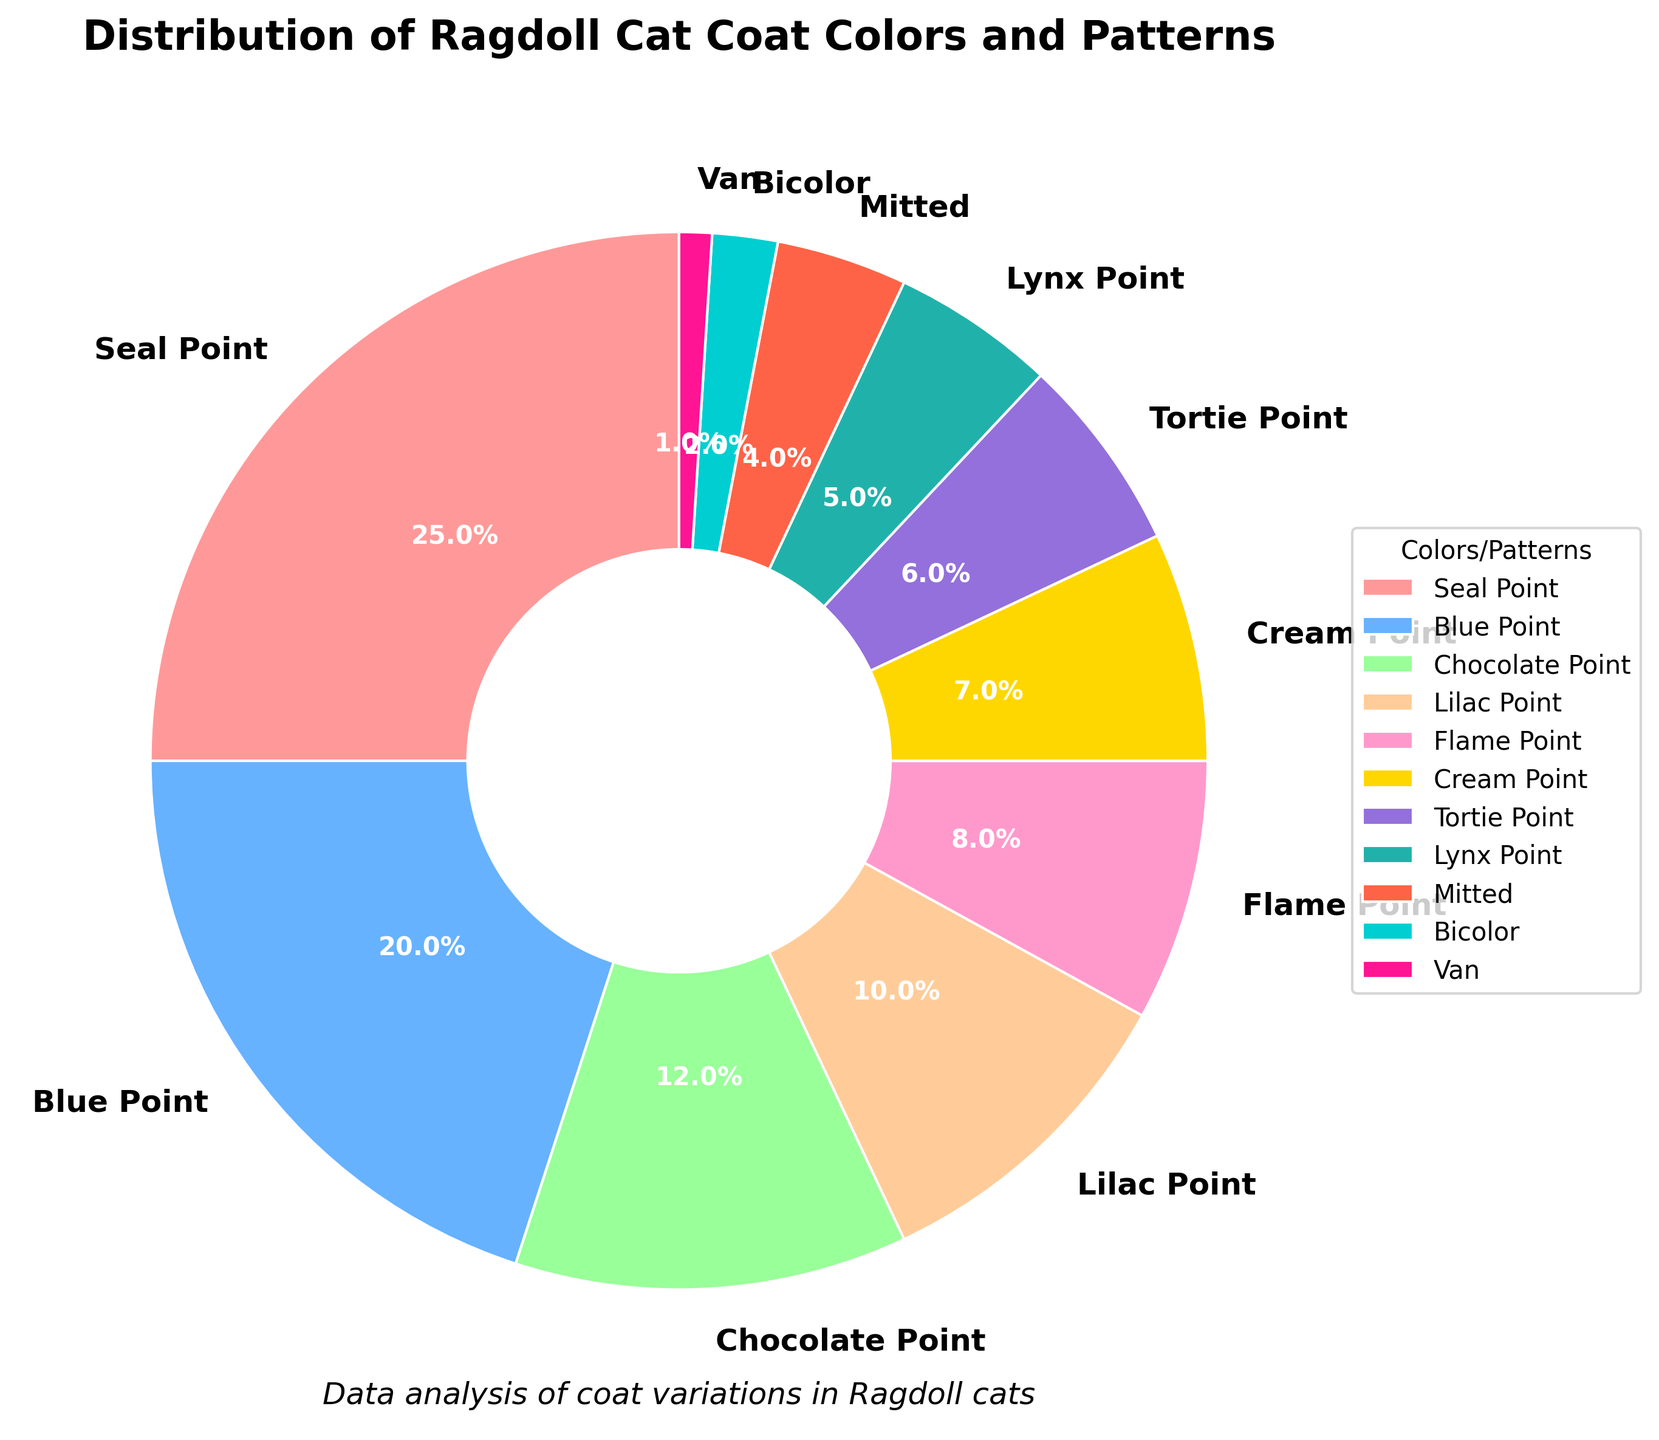What is the most common coat color/pattern in Ragdoll cats? The figure shows a pie chart. The largest segment represents the Seal Point, which has a larger portion than any other color/pattern.
Answer: Seal Point Which coat color/pattern contributes the least to the distribution? The pie chart's smallest segment corresponds to the "Van" color/pattern, consisting of 1% of the total distribution.
Answer: Van What is the combined percentage of Seal Point and Blue Point in Ragdoll cats? Adding the percentages for Seal Point (25%) and Blue Point (20%), the calculation is 25% + 20% = 45%.
Answer: 45% How does the prevalence of Mitted compare to Bicolor? The pie chart indicates that Mitted has 4% while Bicolor has 2%. Comparing these, Mitted is twice as prevalent as Bicolor.
Answer: Mitted is twice as much as Bicolor Which two coat colors/patterns together make up exactly 17%? By examining the chart, the percentages for Cream Point (7%) and Tortie Point (6%) add up to 13%. The correct pair, which totals 17%, is Lilac Point (10%) and Flame Point (8%).
Answer: Lilac Point and Flame Point What is the difference in percentage between Seal Point and Lynx Point? Subtracting the Lynx Point (5%) from Seal Point (25%), the difference is 25% - 5% = 20%.
Answer: 20% Which has a higher percentage, Chocolate Point or Lilac Point and by how much? Chocolate Point is 12% while Lilac Point is 10%. The difference is calculated by 12% - 10% = 2%.
Answer: Chocolate Point by 2% How many coat colors/patterns are represented in the pie chart? Counting each segment in the pie chart, there are a total of 11 different coat colors/patterns displayed.
Answer: 11 What is the median value of the percentages for the coat colors/patterns? Organizing the percentages in ascending order: 1, 2, 4, 5, 6, 7, 8, 10, 12, 20, 25, the middle value in this list (6th position) is 7%.
Answer: 7% If you combine all point patterns (Seal, Blue, Chocolate, Lilac, Flame, Cream, Tortie, and Lynx), what percentage do they form together? Adding the percentages: Seal Point (25), Blue Point (20), Chocolate Point (12), Lilac Point (10), Flame Point (8), Cream Point (7), Tortie Point (6), and Lynx Point (5), the sum is 93%.
Answer: 93% 